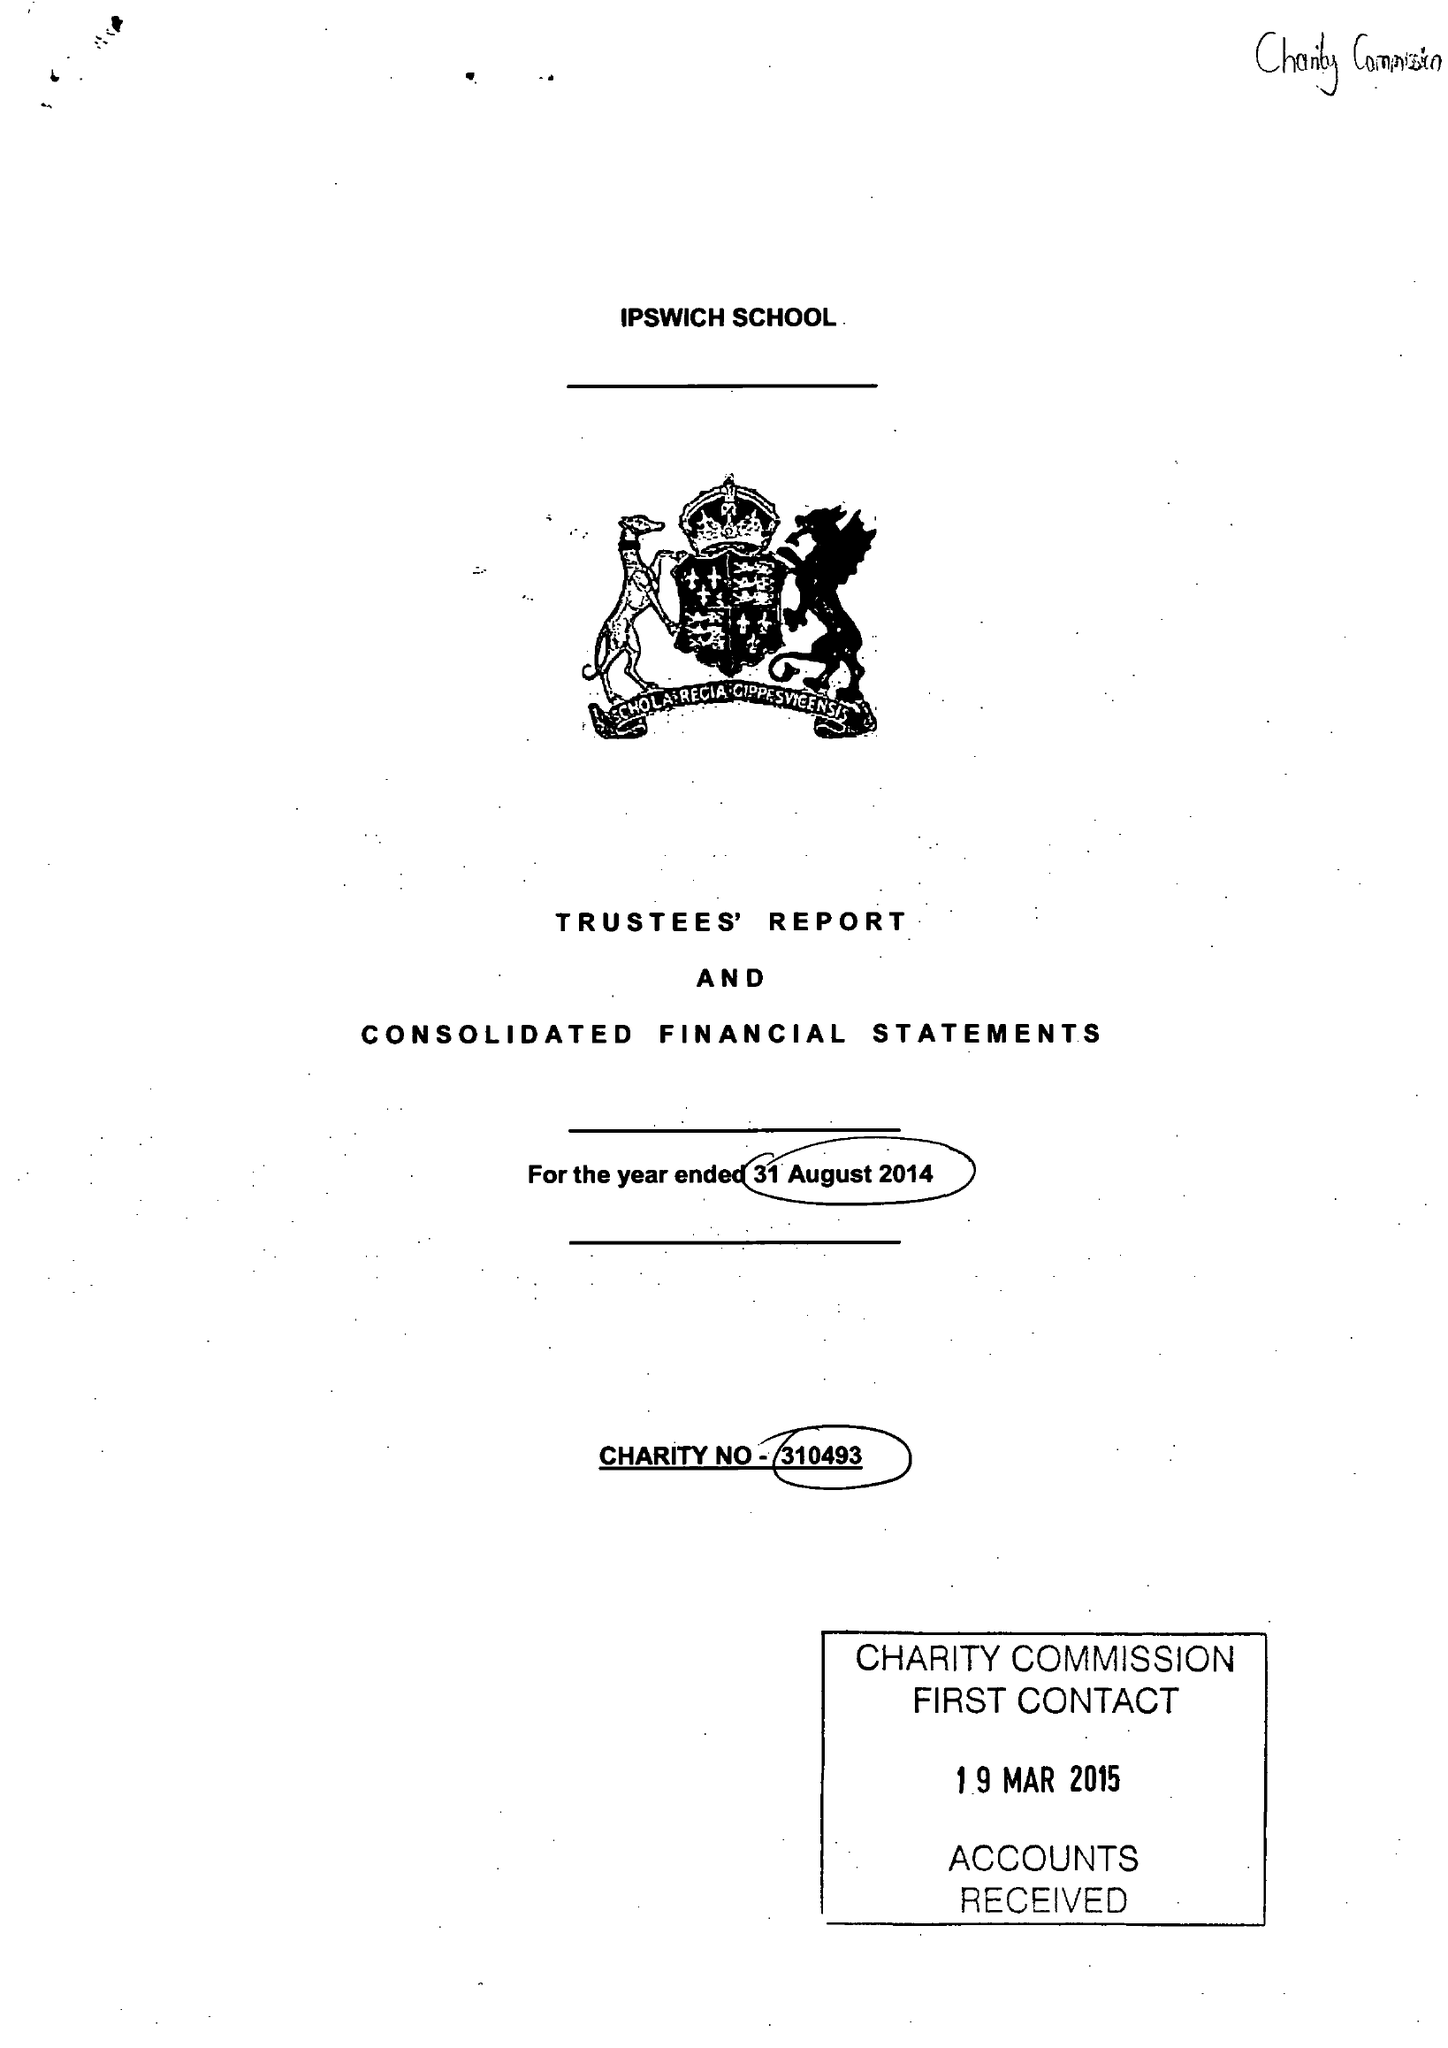What is the value for the spending_annually_in_british_pounds?
Answer the question using a single word or phrase. 12769988.00 